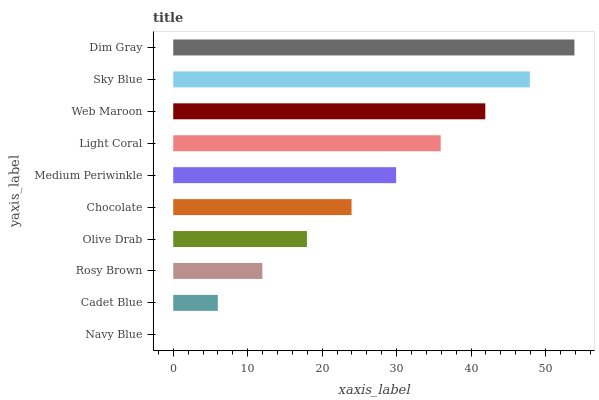Is Navy Blue the minimum?
Answer yes or no. Yes. Is Dim Gray the maximum?
Answer yes or no. Yes. Is Cadet Blue the minimum?
Answer yes or no. No. Is Cadet Blue the maximum?
Answer yes or no. No. Is Cadet Blue greater than Navy Blue?
Answer yes or no. Yes. Is Navy Blue less than Cadet Blue?
Answer yes or no. Yes. Is Navy Blue greater than Cadet Blue?
Answer yes or no. No. Is Cadet Blue less than Navy Blue?
Answer yes or no. No. Is Medium Periwinkle the high median?
Answer yes or no. Yes. Is Chocolate the low median?
Answer yes or no. Yes. Is Chocolate the high median?
Answer yes or no. No. Is Olive Drab the low median?
Answer yes or no. No. 